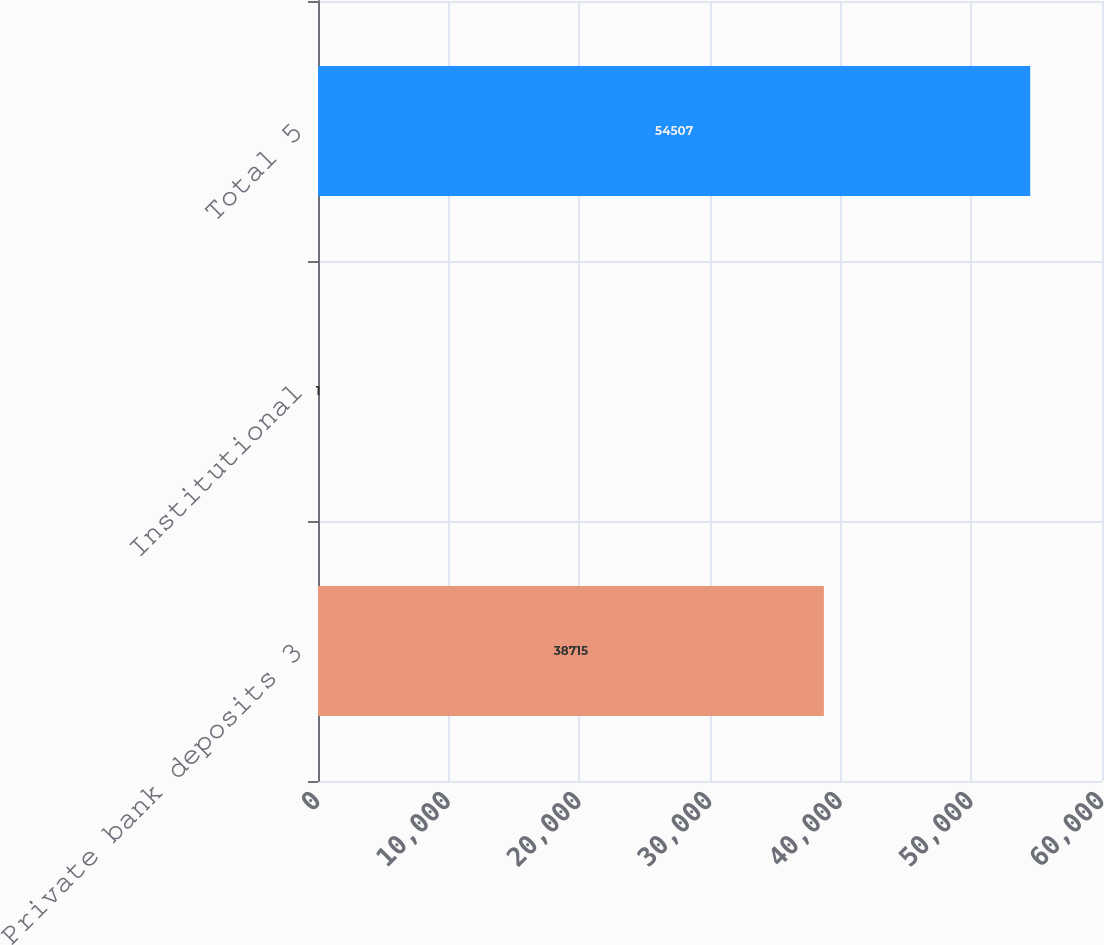<chart> <loc_0><loc_0><loc_500><loc_500><bar_chart><fcel>Private bank deposits 3<fcel>Institutional<fcel>Total 5<nl><fcel>38715<fcel>1<fcel>54507<nl></chart> 